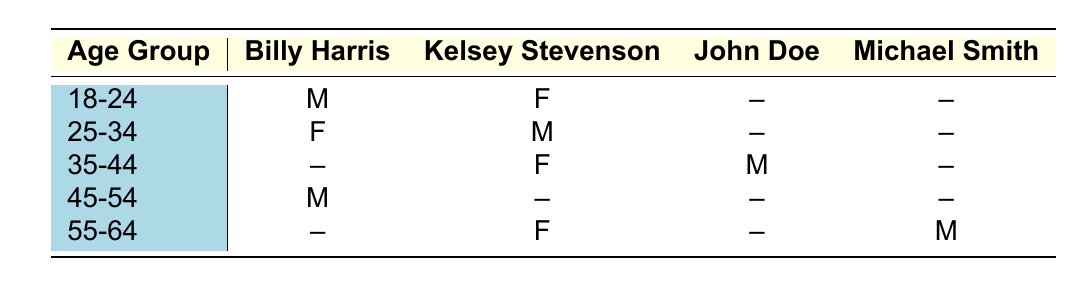What is the favorite athlete of 18-24 year old males? In the table, we look at the first row under the age group 18-24 and find that the favorite athlete is Billy Harris for males in this age group.
Answer: Billy Harris How many females in the 25-34 age group favor Kelsey Stevenson? In the table, there is only one female listed in the 25-34 age group, and her favorite athlete is Kelsey Stevenson, as shown in the second row.
Answer: 1 Is there any male fan in the 45-54 age group who prefers Kelsey Stevenson? Looking at the 45-54 age group in the table, we see that the male fan's favorite athlete is Billy Harris, and Kelsey Stevenson is not listed for this age group, confirming there are none.
Answer: No What is the total number of fans who favor Billy Harris across all age groups? In the table, we find one fan in the 18-24 age group, one in the 25-34 age group, one in the 45-54 age group. Adding them gives 1 + 1 + 1 = 3 fans.
Answer: 3 Who is the favorite athlete for the 55-64 age group? In the 55-64 age group row, we see two athletes mentioned; Kelsey Stevenson for females and Michael Smith for males. Hence, both are favorites in this age group.
Answer: Kelsey Stevenson and Michael Smith How many total athletes are favored by fans aged 35-44? For the 35-44 age group, there are two fans listed with two different athletes: one prefers Kelsey Stevenson and the other prefers John Doe, totaling two different favorites.
Answer: 2 Does any male in the 55-64 age group favor Billy Harris? Checking the 55-64 age group, we see that Michael Smith is preferred by males, while Billy Harris is not listed for this age group, leading us to the conclusion that there is none.
Answer: No Which age group has the highest representation of Kelsey Stevenson among female fans? In the table, Kelsey Stevenson is favored by females in two age groups: 25-34 and 35-44 (both being females). Both groups contribute equally, with one female each, making it a tie.
Answer: 25-34 and 35-44 